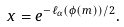Convert formula to latex. <formula><loc_0><loc_0><loc_500><loc_500>x = e ^ { - \ell _ { \alpha } ( \phi ( m ) ) / 2 } .</formula> 